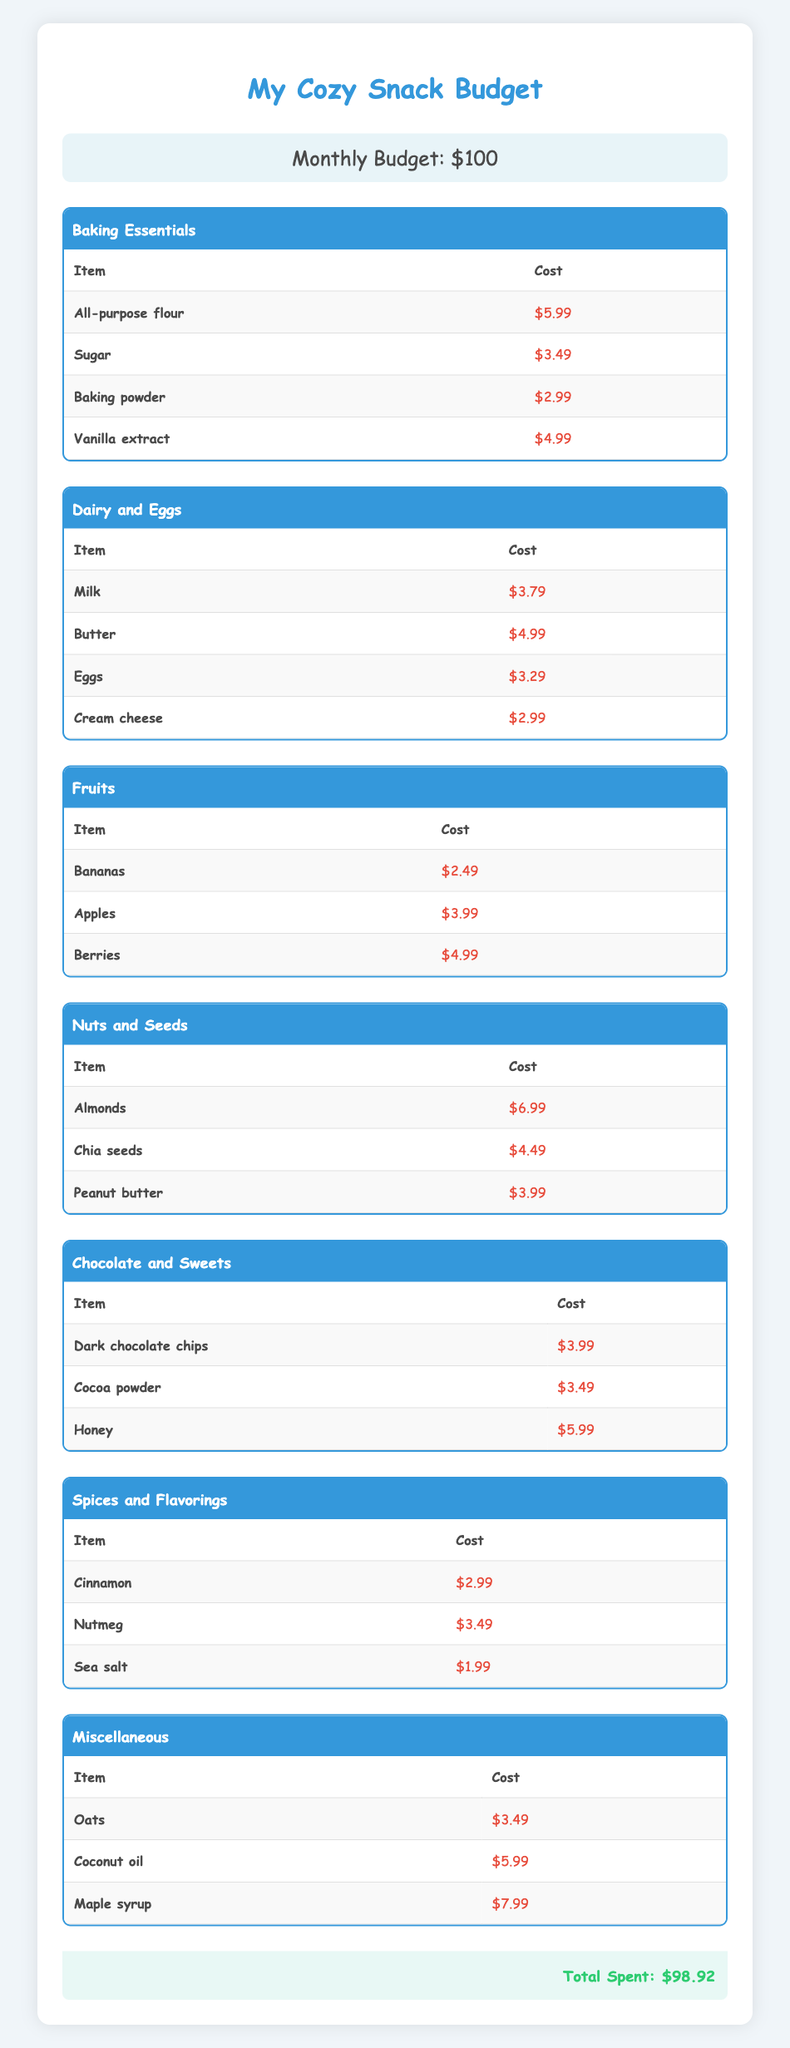What is the total cost of ingredients in the "Baking Essentials" category? The table lists four items under "Baking Essentials": All-purpose flour ($5.99), Sugar ($3.49), Baking powder ($2.99), and Vanilla extract ($4.99). Adding these costs together: 5.99 + 3.49 + 2.99 + 4.99 = 17.46.
Answer: 17.46 How much money will be left after purchasing all the ingredients? The total cost of all ingredients in the table is $98.92. The monthly budget is $100. Therefore, we subtract the total cost from the budget: 100 - 98.92 = 1.08.
Answer: 1.08 Is the cost of "Honey" less than the cost of "Cream cheese"? The cost of Honey is $5.99 and the cost of Cream cheese is $2.99. Since 5.99 is greater than 2.99, the statement is false.
Answer: No What is the sum of costs for ingredients in the "Nuts and Seeds" category? There are three items in the "Nuts and Seeds" category: Almonds ($6.99), Chia seeds ($4.49), and Peanut butter ($3.99). Adding these together gives: 6.99 + 4.49 + 3.99 = 15.47.
Answer: 15.47 How many categories have at least one item costing more than $5? Looking at all categories: "Dairy and Eggs" has Butter ($4.99) but does not exceed $5. "Nuts and Seeds" has Almonds ($6.99), which does. "Chocolate and Sweets" has Honey ($5.99). "Miscellaneous" has Maple syrup ($7.99). This totals to 3 categories.
Answer: 3 What is the average cost of items in the "Fruits" category? The Fruits category contains three items: Bananas ($2.49), Apples ($3.99), and Berries ($4.99). The total cost is 2.49 + 3.99 + 4.99 = 11.47. There are 3 items, so the average cost is 11.47 / 3 = 3.82.
Answer: 3.82 Is the total cost of ingredients in "Chocolate and Sweets" category equal to 13? The "Chocolate and Sweets" category has three items: Dark chocolate chips ($3.99), Cocoa powder ($3.49), and Honey ($5.99). The total is 3.99 + 3.49 + 5.99 = 13.47, which is not equal to 13, so the statement is false.
Answer: No What is the most expensive single item in the table? Scanning through the costs from all categories, Maple syrup in the "Miscellaneous" category costs $7.99, which is the highest compared to all other items listed.
Answer: Maple syrup How do the total costs of "Dairy and Eggs" compare to "Spices and Flavorings"? First, we find the total for "Dairy and Eggs" which includes Milk ($3.79), Butter ($4.99), Eggs ($3.29), and Cream cheese ($2.99), totaling $15.06. For "Spices and Flavorings", we have Cinnamon ($2.99), Nutmeg ($3.49), and Sea salt ($1.99), adding to $8.47. Comparing the two gives: 15.06 > 8.47.
Answer: Dairy and Eggs is higher 